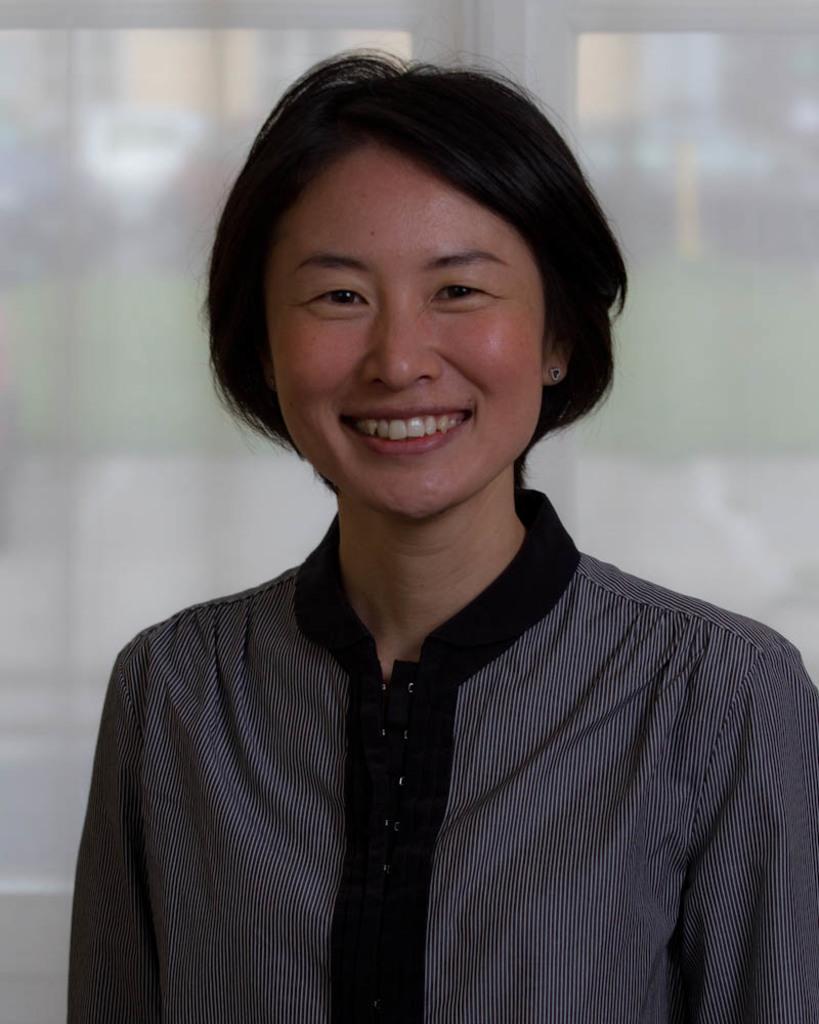Could you give a brief overview of what you see in this image? In this image, we can see a person standing and smiling, in the background we can see the windows. 